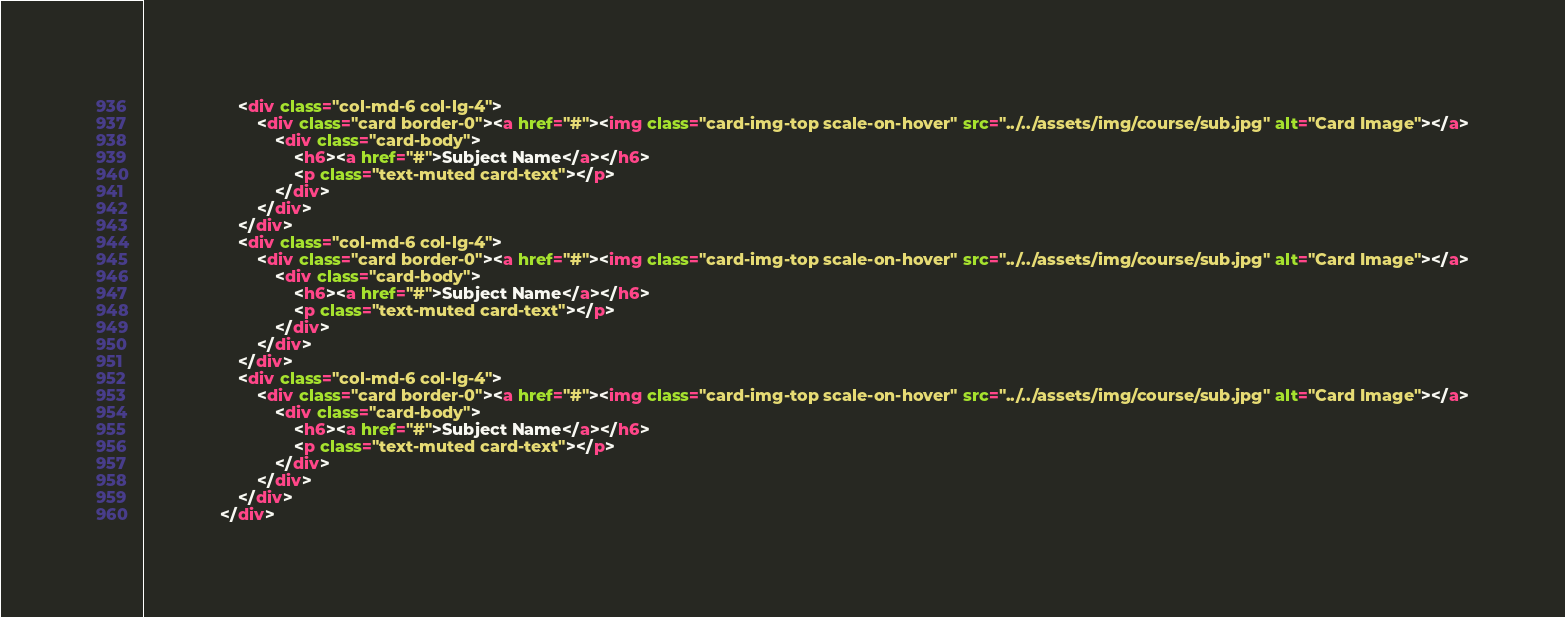Convert code to text. <code><loc_0><loc_0><loc_500><loc_500><_HTML_>                    <div class="col-md-6 col-lg-4">
                        <div class="card border-0"><a href="#"><img class="card-img-top scale-on-hover" src="../../assets/img/course/sub.jpg" alt="Card Image"></a>
                            <div class="card-body">
                                <h6><a href="#">Subject Name</a></h6>
                                <p class="text-muted card-text"></p>
                            </div>
                        </div>
                    </div>
                    <div class="col-md-6 col-lg-4">
                        <div class="card border-0"><a href="#"><img class="card-img-top scale-on-hover" src="../../assets/img/course/sub.jpg" alt="Card Image"></a>
                            <div class="card-body">
                                <h6><a href="#">Subject Name</a></h6>
                                <p class="text-muted card-text"></p>
                            </div>
                        </div>
                    </div>
                    <div class="col-md-6 col-lg-4">
                        <div class="card border-0"><a href="#"><img class="card-img-top scale-on-hover" src="../../assets/img/course/sub.jpg" alt="Card Image"></a>
                            <div class="card-body">
                                <h6><a href="#">Subject Name</a></h6>
                                <p class="text-muted card-text"></p>
                            </div>
                        </div>
                    </div>
                </div></code> 